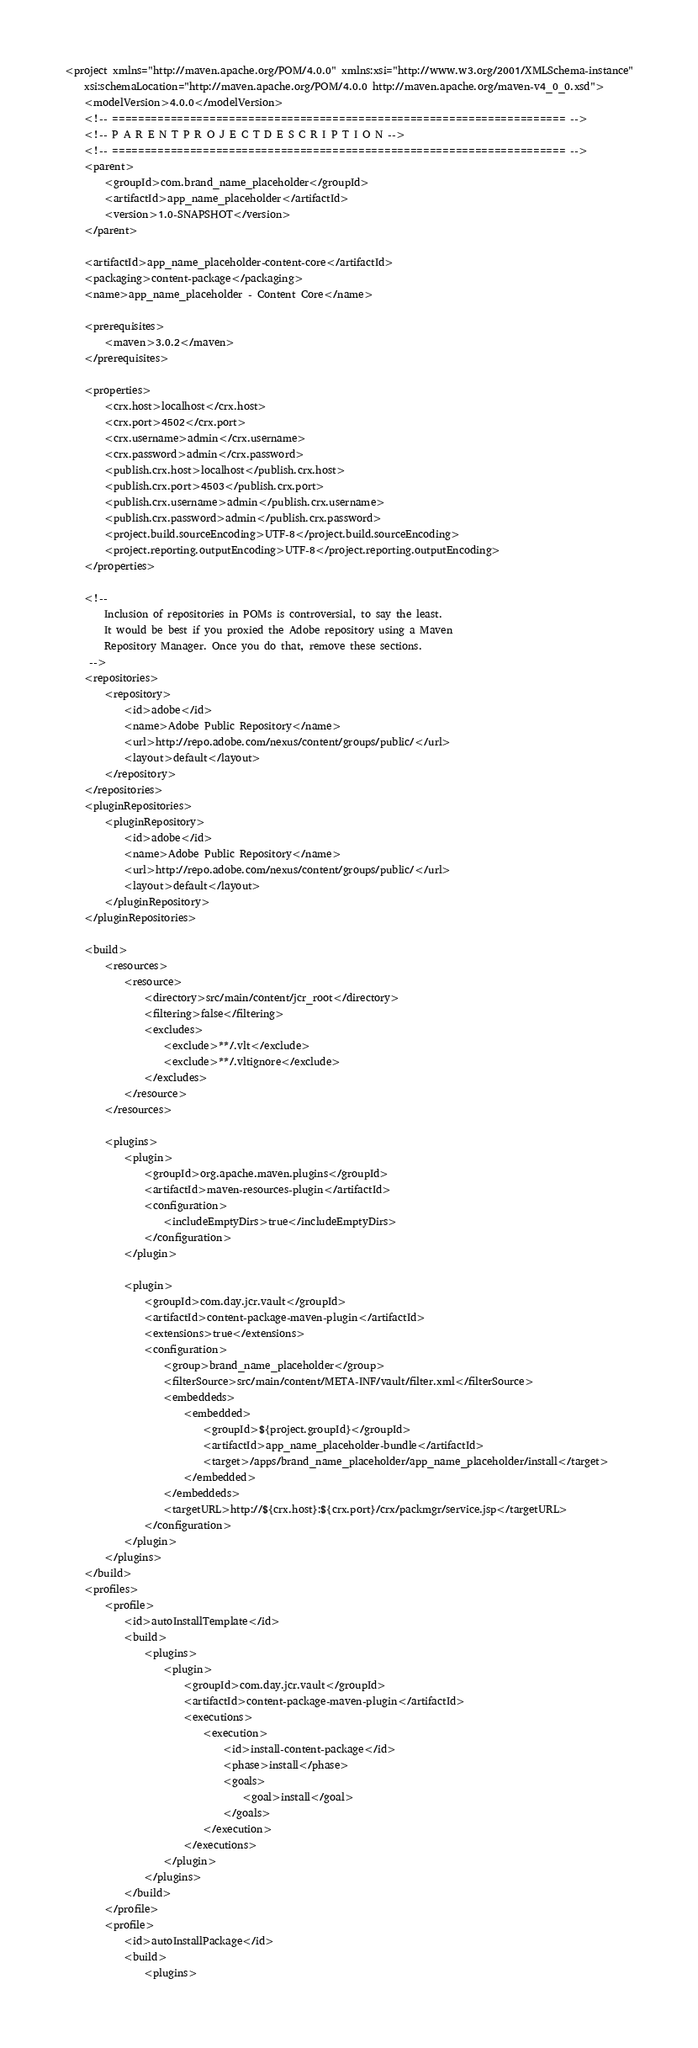Convert code to text. <code><loc_0><loc_0><loc_500><loc_500><_XML_><project xmlns="http://maven.apache.org/POM/4.0.0" xmlns:xsi="http://www.w3.org/2001/XMLSchema-instance"
    xsi:schemaLocation="http://maven.apache.org/POM/4.0.0 http://maven.apache.org/maven-v4_0_0.xsd">
    <modelVersion>4.0.0</modelVersion>
    <!-- ====================================================================== -->
    <!-- P A R E N T P R O J E C T D E S C R I P T I O N -->
    <!-- ====================================================================== -->
    <parent>
        <groupId>com.brand_name_placeholder</groupId>
        <artifactId>app_name_placeholder</artifactId>
        <version>1.0-SNAPSHOT</version>
    </parent>

    <artifactId>app_name_placeholder-content-core</artifactId>
    <packaging>content-package</packaging>
    <name>app_name_placeholder - Content Core</name>

    <prerequisites>
        <maven>3.0.2</maven>
    </prerequisites>

    <properties>
        <crx.host>localhost</crx.host>
        <crx.port>4502</crx.port>
        <crx.username>admin</crx.username>
        <crx.password>admin</crx.password>
        <publish.crx.host>localhost</publish.crx.host>
        <publish.crx.port>4503</publish.crx.port>
        <publish.crx.username>admin</publish.crx.username>
        <publish.crx.password>admin</publish.crx.password>
        <project.build.sourceEncoding>UTF-8</project.build.sourceEncoding>
        <project.reporting.outputEncoding>UTF-8</project.reporting.outputEncoding>
    </properties>

    <!--
        Inclusion of repositories in POMs is controversial, to say the least.
        It would be best if you proxied the Adobe repository using a Maven
        Repository Manager. Once you do that, remove these sections.
     -->
    <repositories>
        <repository>
            <id>adobe</id>
            <name>Adobe Public Repository</name>
            <url>http://repo.adobe.com/nexus/content/groups/public/</url>
            <layout>default</layout>
        </repository>
    </repositories>
    <pluginRepositories>
        <pluginRepository>
            <id>adobe</id>
            <name>Adobe Public Repository</name>
            <url>http://repo.adobe.com/nexus/content/groups/public/</url>
            <layout>default</layout>
        </pluginRepository>
    </pluginRepositories>

    <build>
        <resources>
            <resource>
                <directory>src/main/content/jcr_root</directory>
                <filtering>false</filtering>
                <excludes>
                    <exclude>**/.vlt</exclude>
                    <exclude>**/.vltignore</exclude>
                </excludes>
            </resource>
        </resources>

        <plugins>
            <plugin>
                <groupId>org.apache.maven.plugins</groupId>
                <artifactId>maven-resources-plugin</artifactId>
                <configuration>
                    <includeEmptyDirs>true</includeEmptyDirs>
                </configuration>
            </plugin>

            <plugin>
                <groupId>com.day.jcr.vault</groupId>
                <artifactId>content-package-maven-plugin</artifactId>
                <extensions>true</extensions>
                <configuration>
                    <group>brand_name_placeholder</group>
                    <filterSource>src/main/content/META-INF/vault/filter.xml</filterSource>
                    <embeddeds>
                        <embedded>
                            <groupId>${project.groupId}</groupId>
                            <artifactId>app_name_placeholder-bundle</artifactId>
                            <target>/apps/brand_name_placeholder/app_name_placeholder/install</target>
                        </embedded>
                    </embeddeds>
                    <targetURL>http://${crx.host}:${crx.port}/crx/packmgr/service.jsp</targetURL>
                </configuration>
            </plugin>
        </plugins>
    </build>
    <profiles>
        <profile>
            <id>autoInstallTemplate</id>
            <build>
                <plugins>
                    <plugin>
                        <groupId>com.day.jcr.vault</groupId>
                        <artifactId>content-package-maven-plugin</artifactId>
                        <executions>
                            <execution>
                                <id>install-content-package</id>
                                <phase>install</phase>
                                <goals>
                                    <goal>install</goal>
                                </goals>
                            </execution>
                        </executions>
                    </plugin>
                </plugins>
            </build>
        </profile>
        <profile>
            <id>autoInstallPackage</id>
            <build>
                <plugins></code> 